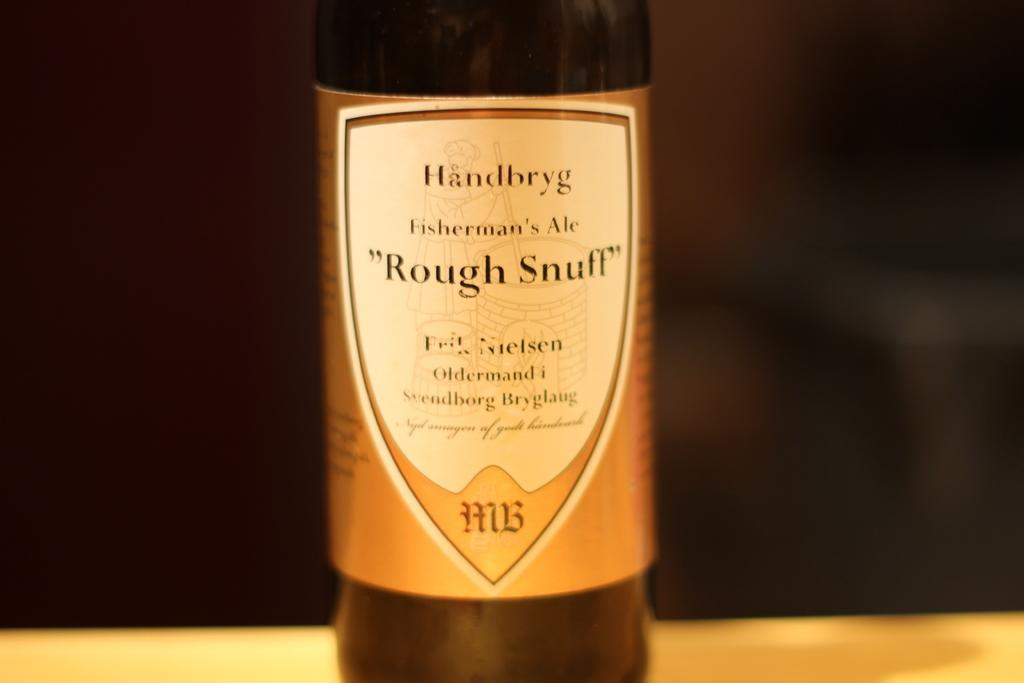<image>
Create a compact narrative representing the image presented. A bottle of Fisherman's Ale called "Rough Snuff" has a gold label. 